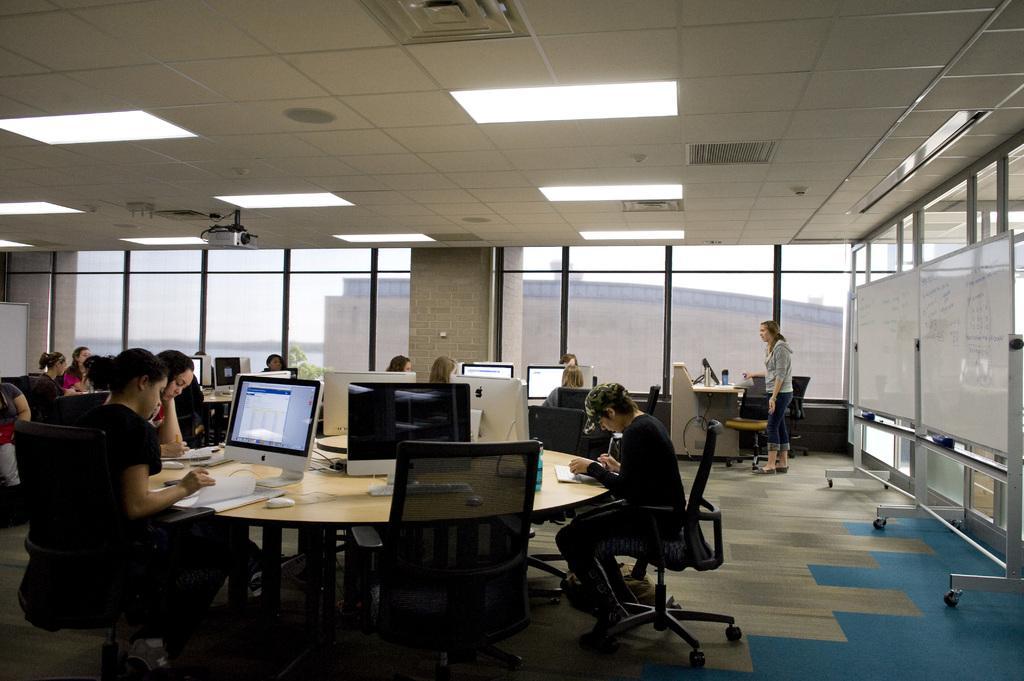Could you give a brief overview of what you see in this image? there is a table on which there are many computer screens. people are sitting around tables. at the right there are white boards. at the back there are windows and at the top there is a projector. 